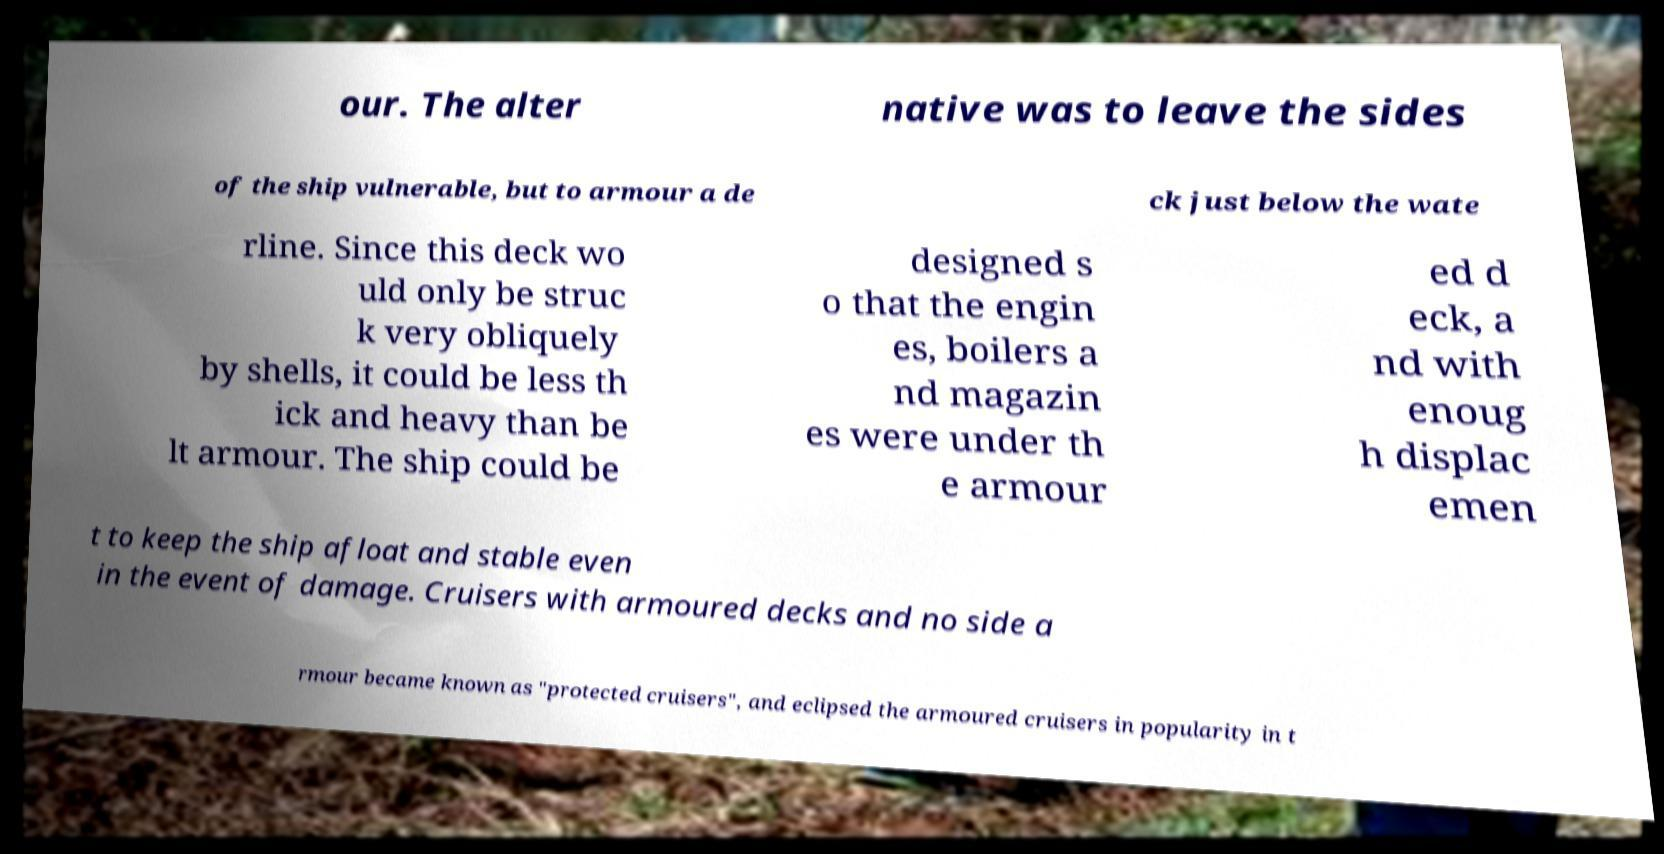Could you assist in decoding the text presented in this image and type it out clearly? our. The alter native was to leave the sides of the ship vulnerable, but to armour a de ck just below the wate rline. Since this deck wo uld only be struc k very obliquely by shells, it could be less th ick and heavy than be lt armour. The ship could be designed s o that the engin es, boilers a nd magazin es were under th e armour ed d eck, a nd with enoug h displac emen t to keep the ship afloat and stable even in the event of damage. Cruisers with armoured decks and no side a rmour became known as "protected cruisers", and eclipsed the armoured cruisers in popularity in t 